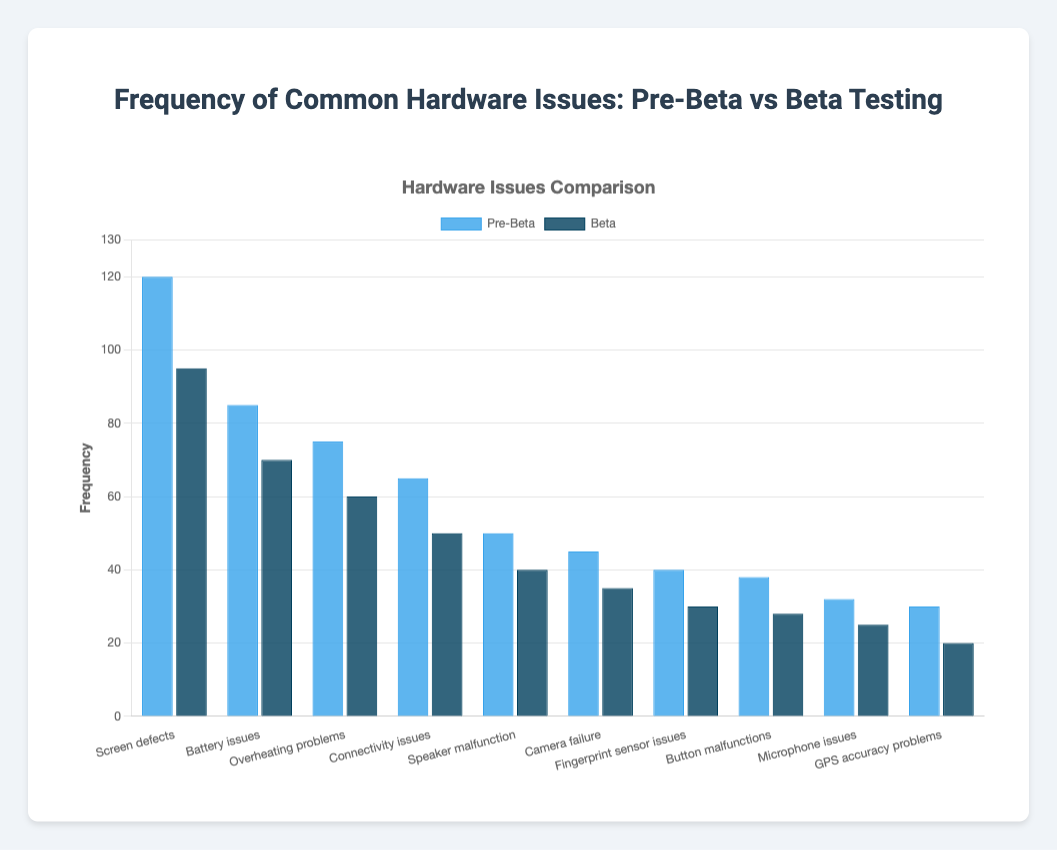Which hardware issue had the highest frequency in the pre-beta phase? The bar labeled "Screen defects" is the tallest in the pre-beta dataset, indicating the highest frequency.
Answer: Screen defects Which hardware issue saw the largest reduction in frequency from pre-beta to beta testing? By comparing the heights of the bars, "Screen defects" reduced from 120 to 95, a decrease of 25, which is the largest reduction.
Answer: Screen defects What is the combined frequency of "Battery issues" and "Connectivity issues" in the beta testing phase? In the beta phase, "Battery issues" has a frequency of 70 and "Connectivity issues" has a frequency of 50. Adding them together gives 70 + 50 = 120.
Answer: 120 How many hardware issues had a frequency below 50 in the pre-beta phase? The bars below the 50 mark are “Button malfunctions”, “Microphone issues”, and “GPS accuracy problems”. There are three such bars.
Answer: 3 Which hardware issue had the exact same frequency difference between pre-beta and beta testing as "Overheating problems"? For “Overheating problems”, the frequency difference is 75 - 60 = 15. The same difference can be found for “Battery issues” (85 - 70 = 15) and "Screen defects" (120 - 95 = 25). After confirming, only "Battery issues" has the same exact difference of 15.
Answer: Battery issues What is the percentage decrease in frequency of "Fingerprint sensor issues" from pre-beta to beta testing? The frequency of "Fingerprint sensor issues" decreased from 40 to 30. The percentage decrease is calculated as ((40 - 30) / 40) * 100 = 25%.
Answer: 25% Which phase had more instances reported of "Camera failure": pre-beta or beta? Comparing the height of the "Camera failure" bars, pre-beta is taller than beta. Pre-beta had 45 and beta had 35 instances.
Answer: pre-beta How does the frequency of "Button malfunctions" in beta compare to the frequency of "GPS accuracy problems" in pre-beta? The frequency of "Button malfunctions" in beta is 28, and the frequency of "GPS accuracy problems" in pre-beta is 30. Therefore, “Button malfunctions” in beta is slightly less than "GPS accuracy problems" in pre-beta.
Answer: less than How many issues have a frequency of 50 or above in the pre-beta phase? The issues are “Screen defects” (120), “Battery issues” (85), “Overheating problems” (75), "Connectivity issues" (65), and "Speaker malfunction" (50). So, there are 5 issues.
Answer: 5 Which hardware issue had the smallest frequency in the beta testing phase? Comparing all the beta phase bars, "GPS accuracy problems" shows the shortest bar at a frequency of 20.
Answer: GPS accuracy problems 